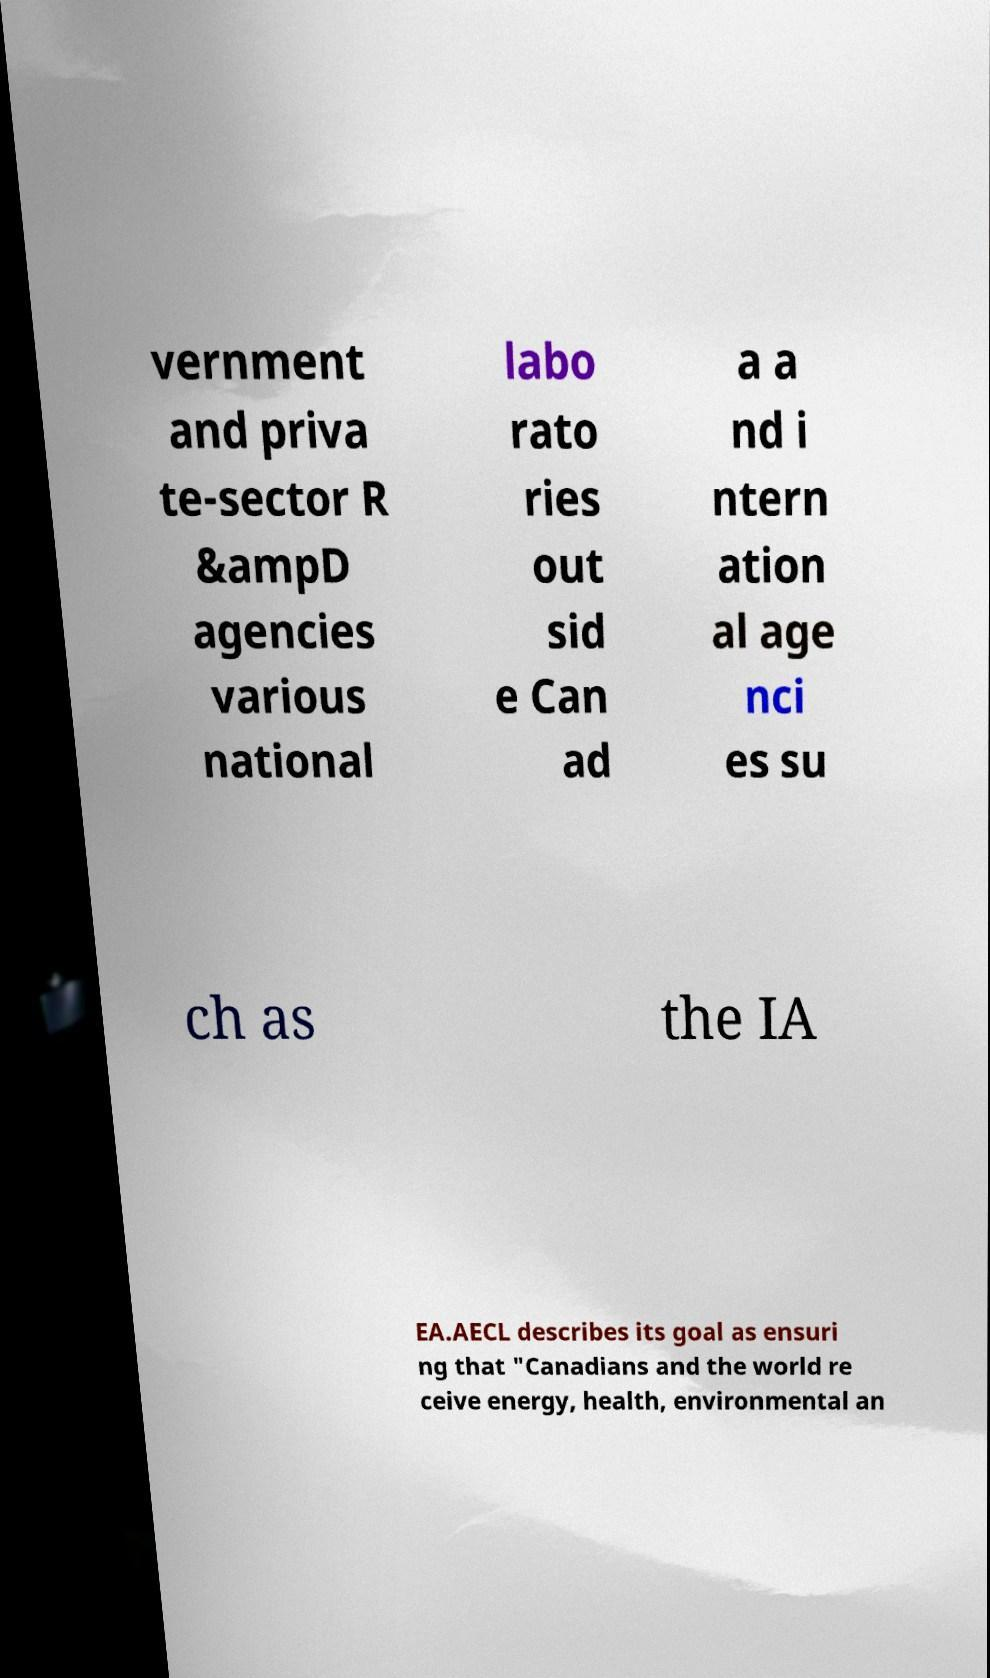There's text embedded in this image that I need extracted. Can you transcribe it verbatim? vernment and priva te-sector R &ampD agencies various national labo rato ries out sid e Can ad a a nd i ntern ation al age nci es su ch as the IA EA.AECL describes its goal as ensuri ng that "Canadians and the world re ceive energy, health, environmental an 